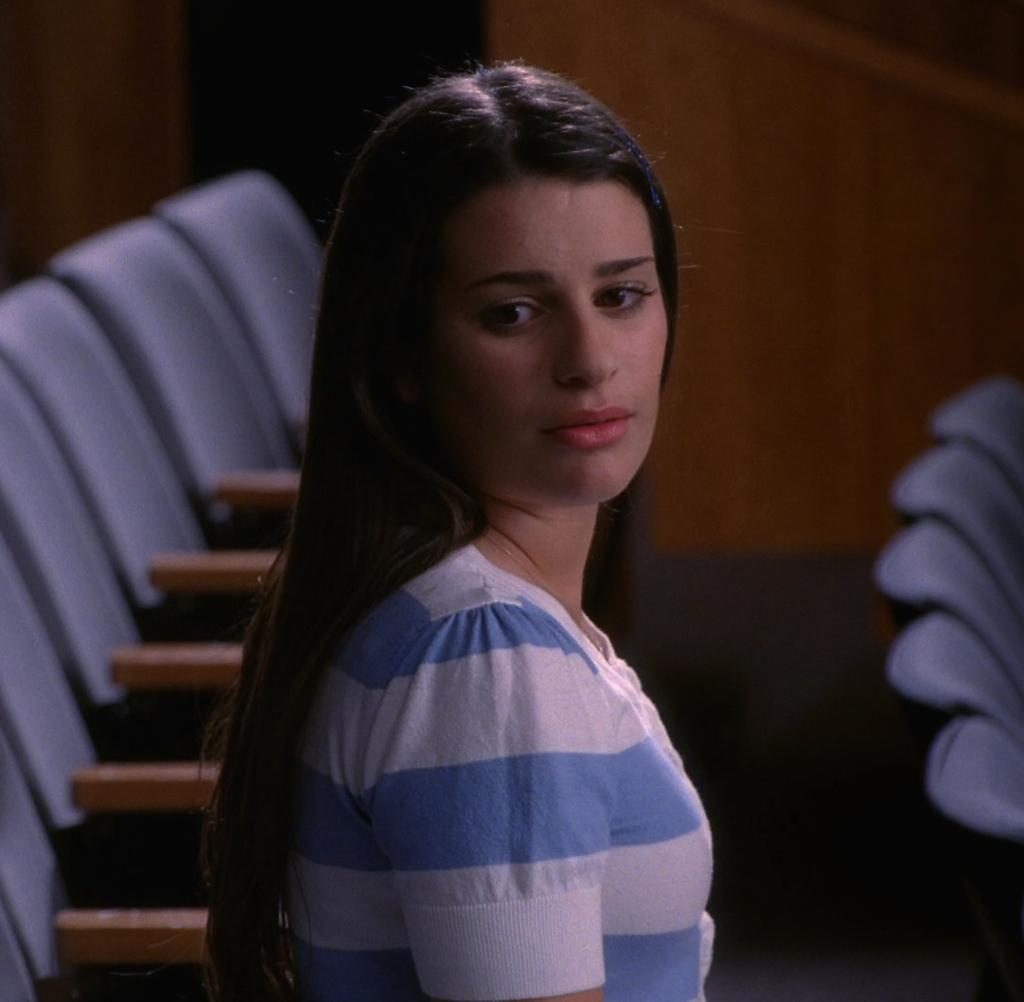What is the woman in the image doing? The woman is sitting on a chair in the image. Can you describe the chairs in the background of the image? There are empty chairs in the background of the image. How does the woman fold the chair she is sitting on in the image? The woman is not folding the chair in the image; she is sitting on it. 